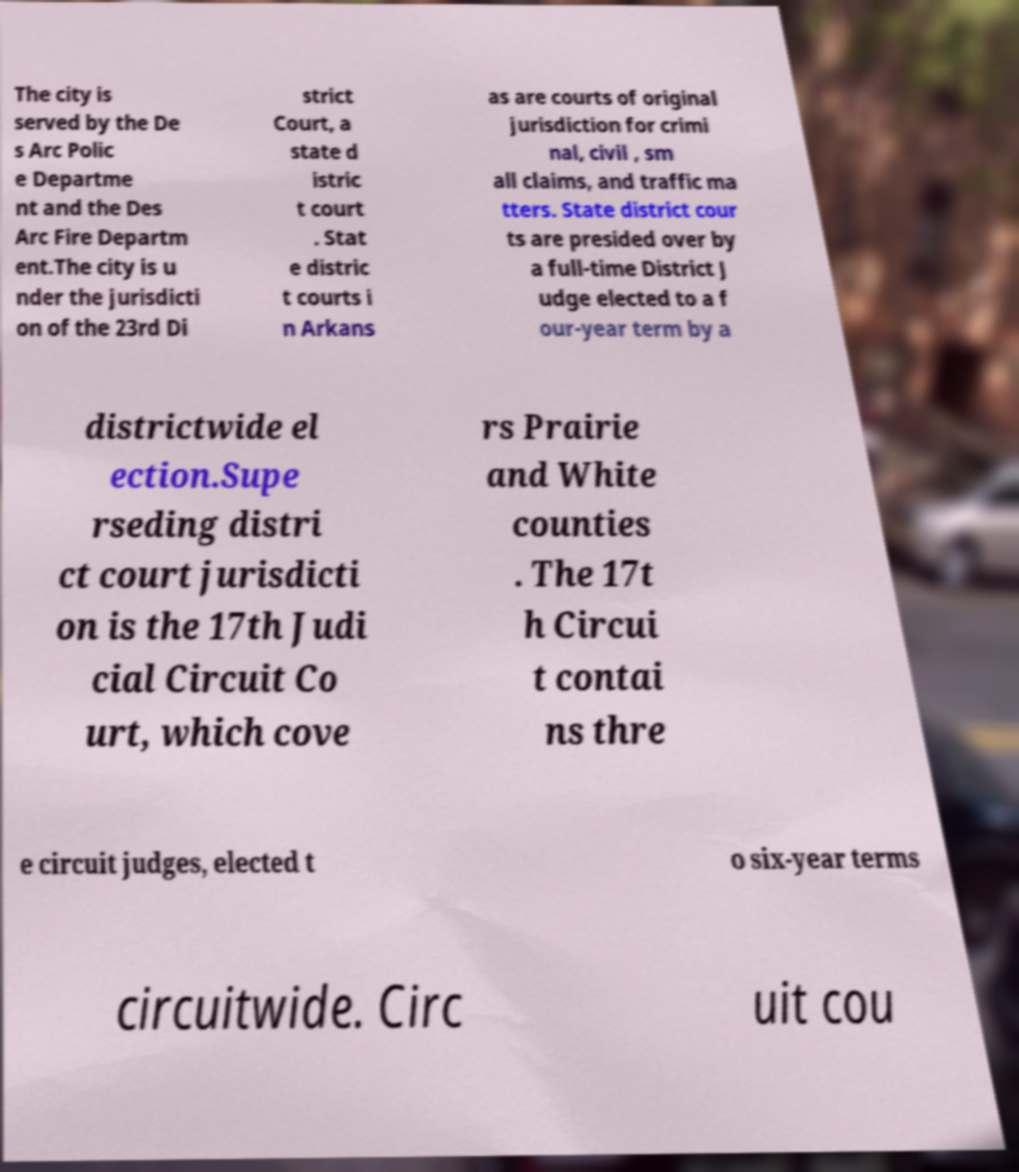For documentation purposes, I need the text within this image transcribed. Could you provide that? The city is served by the De s Arc Polic e Departme nt and the Des Arc Fire Departm ent.The city is u nder the jurisdicti on of the 23rd Di strict Court, a state d istric t court . Stat e distric t courts i n Arkans as are courts of original jurisdiction for crimi nal, civil , sm all claims, and traffic ma tters. State district cour ts are presided over by a full-time District J udge elected to a f our-year term by a districtwide el ection.Supe rseding distri ct court jurisdicti on is the 17th Judi cial Circuit Co urt, which cove rs Prairie and White counties . The 17t h Circui t contai ns thre e circuit judges, elected t o six-year terms circuitwide. Circ uit cou 